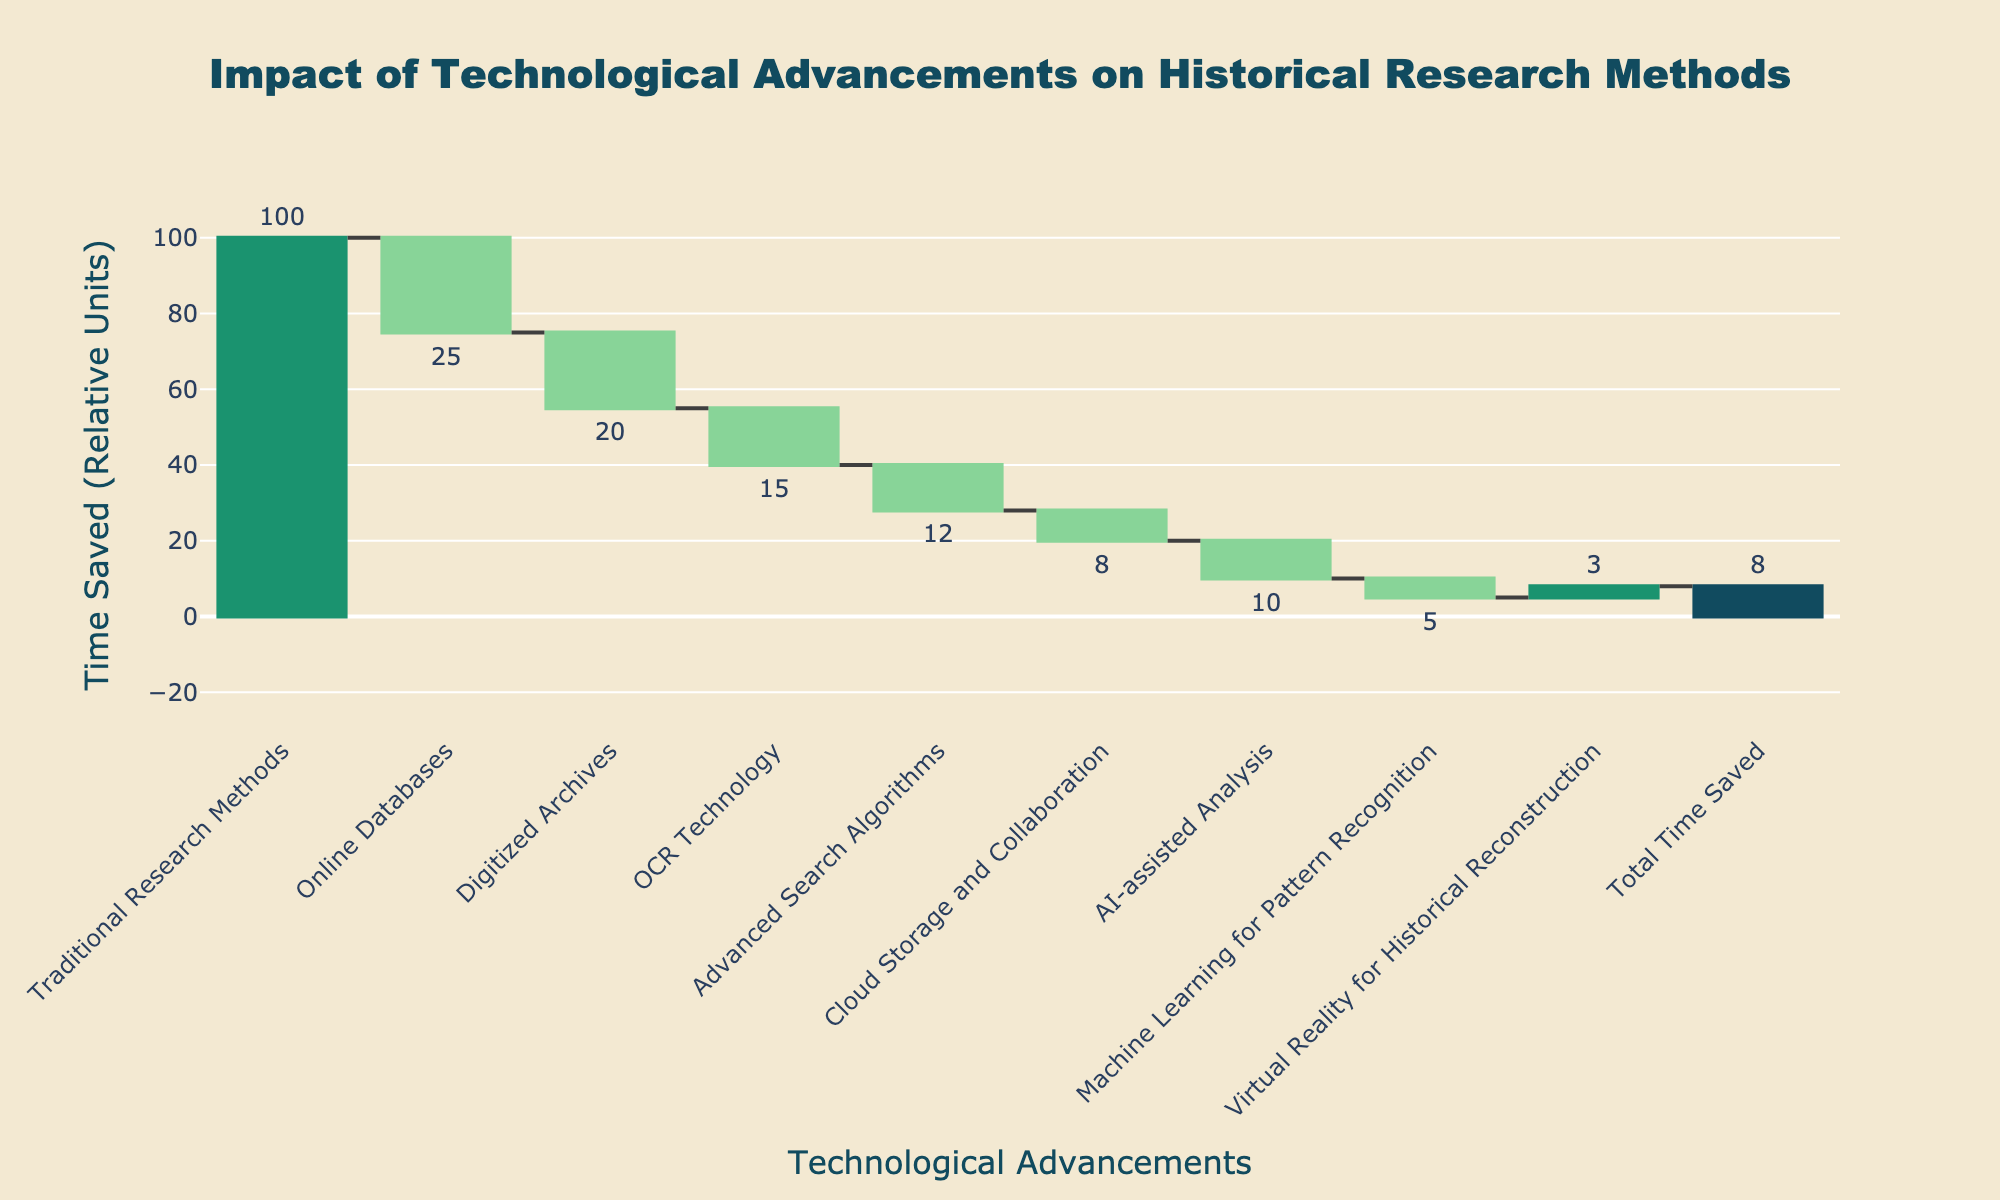what is the title of the chart? The title is prominently displayed at the top of the chart and indicates the primary focus of the visual information. It reads: "Impact of Technological Advancements on Historical Research Methods".
Answer: Impact of Technological Advancements on Historical Research Methods What is the vertical axis labeled on the chart? The vertical axis label is visible to the left of the chart, and it describes the measurement units presented. It is labeled as "Time Saved (Relative Units)".
Answer: Time Saved (Relative Units) How many technological advancements are listed before the 'Total Time Saved'? By examining the x-axis labels, we can enumerate the different technological advancements listed before the 'Total Time Saved' entry. These labels include Traditional Research Methods, Online Databases, Digitized Archives, OCR Technology, Advanced Search Algorithms, Cloud Storage and Collaboration, AI-assisted Analysis, Machine Learning for Pattern Recognition, and Virtual Reality for Historical Reconstruction. Counting these, we have 9 technological advancements listed.
Answer: 9 Which technological advancement contributed the highest relative value of time saved? By identifying the category with the highest absolute (positive) bar value on the chart, we see that Traditional Research Methods contributed the highest relative value of 100 units of time saved.
Answer: Traditional Research Methods What is the total time saved according to the chart? The 'Total Time Saved' is explicitly labeled on the x-axis and is indicated by the final bar on the chart. The value written on this bar is provided as 8.
Answer: 8 What is the difference in time saved between 'OCR Technology' and 'AI-assisted Analysis'? According to the chart, the values for 'OCR Technology' and 'AI-assisted Analysis' are -15 and -10 respectively. The difference between these values is calculated as 15 - 10 (ignoring the signs for a moment) = 5 relative units.
Answer: 5 How does the impact of 'Advanced Search Algorithms' compare to 'Digitized Archives'? Referring to the chart, 'Advanced Search Algorithms' resulted in a time saving value of -12, whereas 'Digitized Archives' resulted in -20. Since -12 is closer to zero than -20, 'Advanced Search Algorithms' had a less negative impact compared to 'Digitized Archives'.
Answer: Advanced Search Algorithms had a less negative impact Which technological advancement shows a positive value of time saved? By looking at the chart bars, the only bar with a positive value is 'Virtual Reality for Historical Reconstruction,' which shows a value of +3.
Answer: Virtual Reality for Historical Reconstruction How much time was saved by 'Machine Learning for Pattern Recognition'? By locating 'Machine Learning for Pattern Recognition' on the x-axis and checking its corresponding bar value, we see a value of -5 relative units.
Answer: -5 